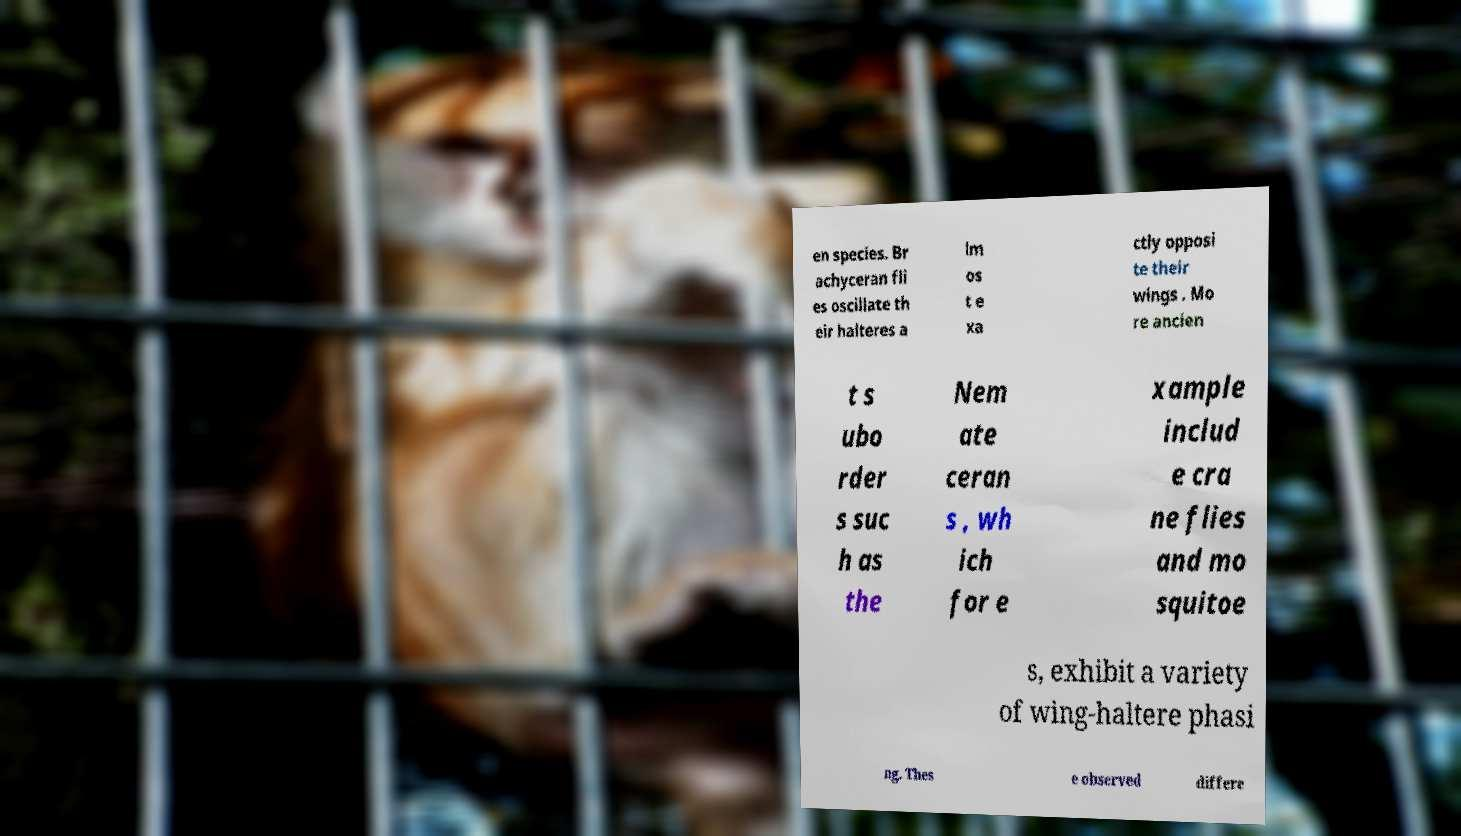Can you accurately transcribe the text from the provided image for me? en species. Br achyceran fli es oscillate th eir halteres a lm os t e xa ctly opposi te their wings . Mo re ancien t s ubo rder s suc h as the Nem ate ceran s , wh ich for e xample includ e cra ne flies and mo squitoe s, exhibit a variety of wing-haltere phasi ng. Thes e observed differe 